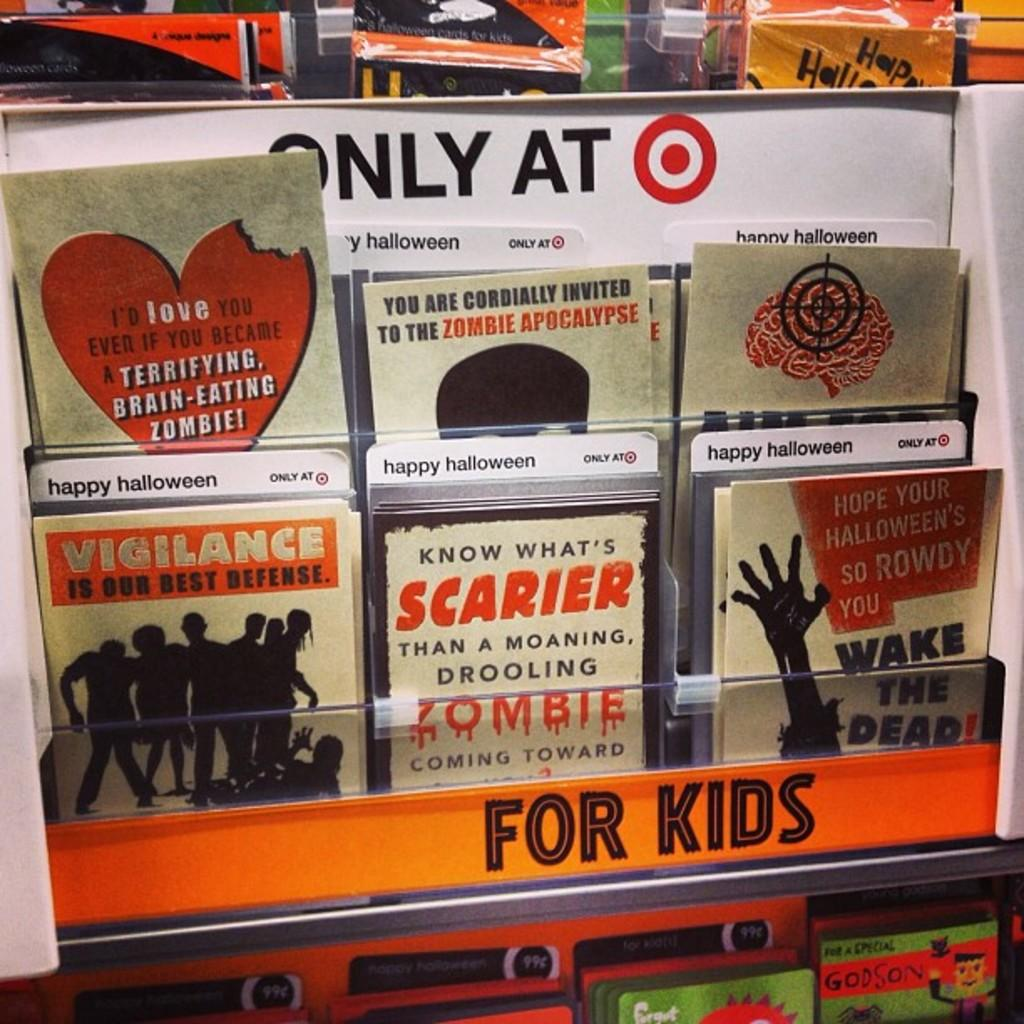<image>
Write a terse but informative summary of the picture. A series of Halloween cards for kids at Target. 